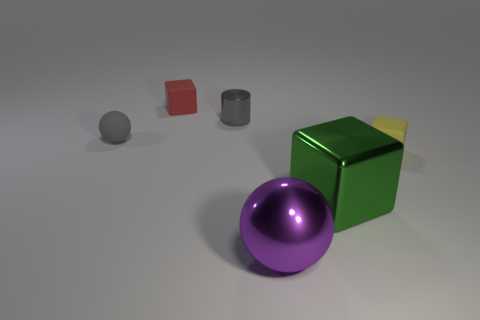Subtract all tiny blocks. How many blocks are left? 1 Subtract all green cubes. How many cubes are left? 2 Add 3 small yellow matte cubes. How many objects exist? 9 Subtract 1 cylinders. How many cylinders are left? 0 Add 6 large cubes. How many large cubes exist? 7 Subtract 0 blue cylinders. How many objects are left? 6 Subtract all spheres. How many objects are left? 4 Subtract all green cylinders. Subtract all purple spheres. How many cylinders are left? 1 Subtract all gray balls. How many green blocks are left? 1 Subtract all large purple metallic spheres. Subtract all gray objects. How many objects are left? 3 